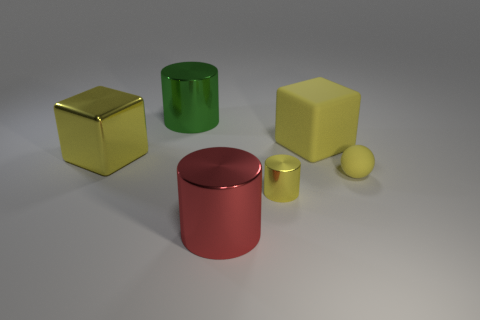Is there any other thing that has the same material as the big red object?
Offer a terse response. Yes. Does the large yellow rubber object have the same shape as the big yellow metallic object?
Your answer should be compact. Yes. There is a big block that is left of the green metal cylinder; what number of green metal objects are left of it?
Provide a short and direct response. 0. What is the material of the small yellow thing that is the same shape as the green metal thing?
Your answer should be very brief. Metal. Do the metal object on the left side of the green cylinder and the sphere have the same color?
Offer a terse response. Yes. Is the yellow cylinder made of the same material as the yellow block on the right side of the yellow metallic cylinder?
Offer a terse response. No. There is a yellow thing that is on the left side of the green metal cylinder; what shape is it?
Make the answer very short. Cube. How many other things are there of the same material as the small yellow ball?
Keep it short and to the point. 1. The yellow sphere has what size?
Ensure brevity in your answer.  Small. How many other objects are the same color as the large rubber thing?
Your answer should be compact. 3. 